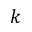<formula> <loc_0><loc_0><loc_500><loc_500>k</formula> 